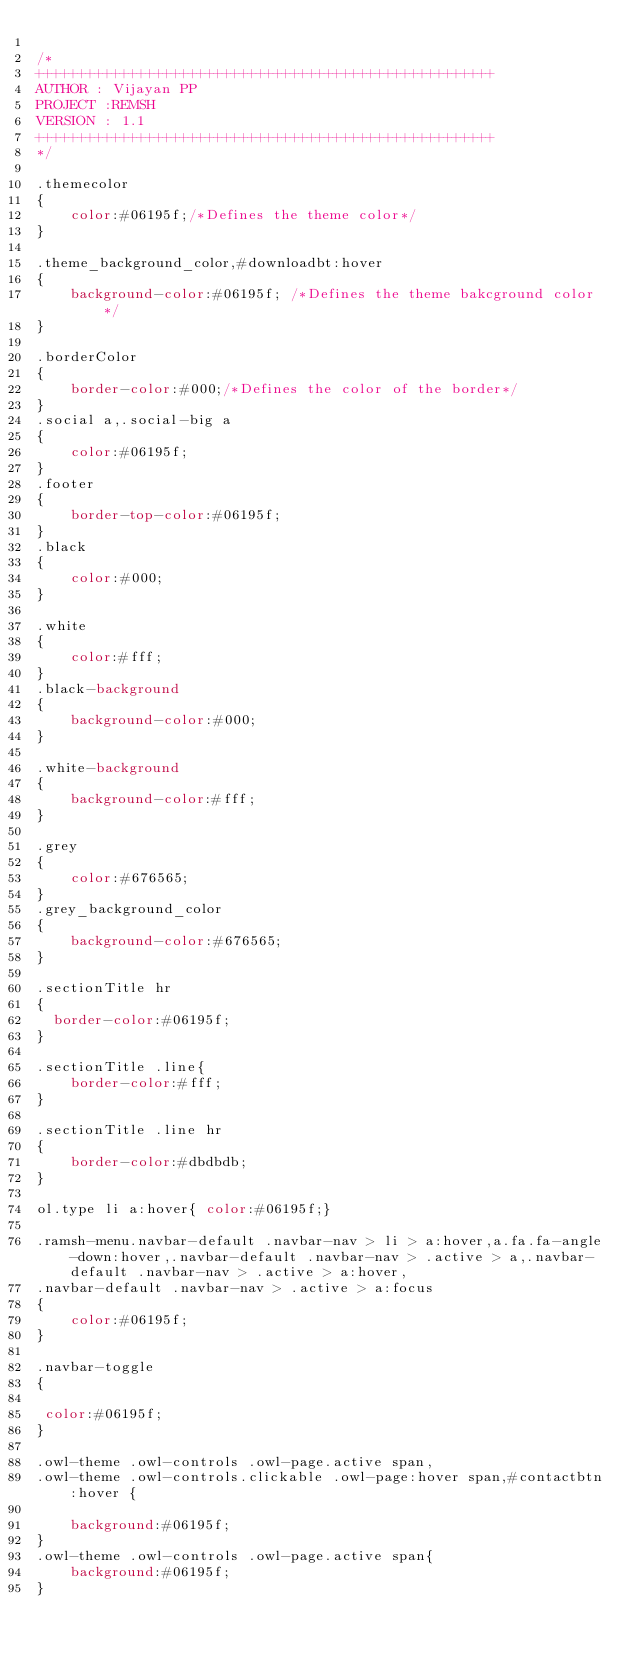<code> <loc_0><loc_0><loc_500><loc_500><_CSS_>
/*
++++++++++++++++++++++++++++++++++++++++++++++++++++++
AUTHOR : Vijayan PP
PROJECT :REMSH
VERSION : 1.1
++++++++++++++++++++++++++++++++++++++++++++++++++++++
*/

.themecolor
{
    color:#06195f;/*Defines the theme color*/
}

.theme_background_color,#downloadbt:hover
{
    background-color:#06195f; /*Defines the theme bakcground color*/
}

.borderColor
{
    border-color:#000;/*Defines the color of the border*/
}
.social a,.social-big a
{
    color:#06195f;
}
.footer
{
    border-top-color:#06195f;
}
.black
{
    color:#000;
}

.white
{
    color:#fff;
}
.black-background
{
    background-color:#000;
}

.white-background
{
    background-color:#fff;
}

.grey
{
    color:#676565;
}
.grey_background_color
{
    background-color:#676565;
}

.sectionTitle hr
{
  border-color:#06195f; 
}

.sectionTitle .line{
    border-color:#fff;
}

.sectionTitle .line hr
{
    border-color:#dbdbdb;
}

ol.type li a:hover{ color:#06195f;}

.ramsh-menu.navbar-default .navbar-nav > li > a:hover,a.fa.fa-angle-down:hover,.navbar-default .navbar-nav > .active > a,.navbar-default .navbar-nav > .active > a:hover, 
.navbar-default .navbar-nav > .active > a:focus
{
    color:#06195f;
}

.navbar-toggle
{
 
 color:#06195f;
}

.owl-theme .owl-controls .owl-page.active span, 
.owl-theme .owl-controls.clickable .owl-page:hover span,#contactbtn:hover {
	
	background:#06195f;
}
.owl-theme .owl-controls .owl-page.active span{
	background:#06195f;
}</code> 